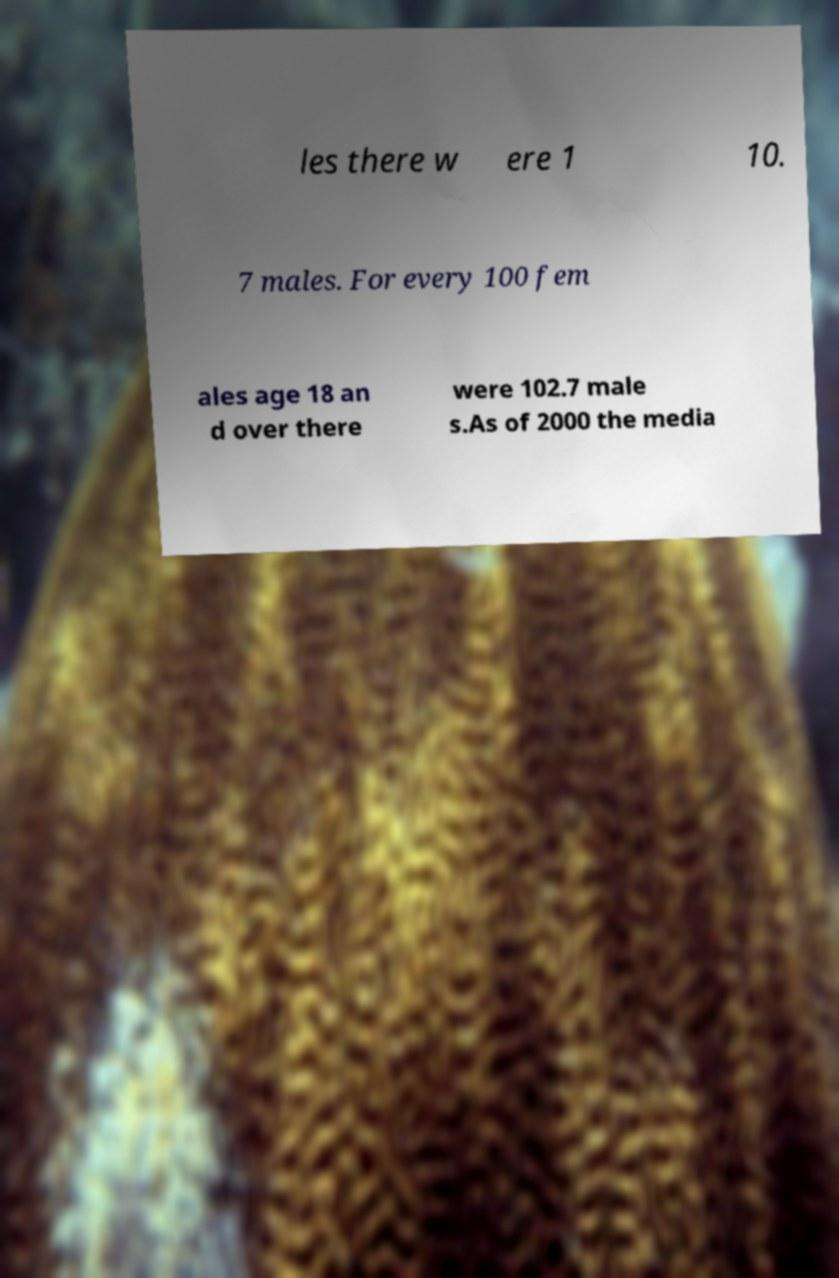Can you accurately transcribe the text from the provided image for me? les there w ere 1 10. 7 males. For every 100 fem ales age 18 an d over there were 102.7 male s.As of 2000 the media 